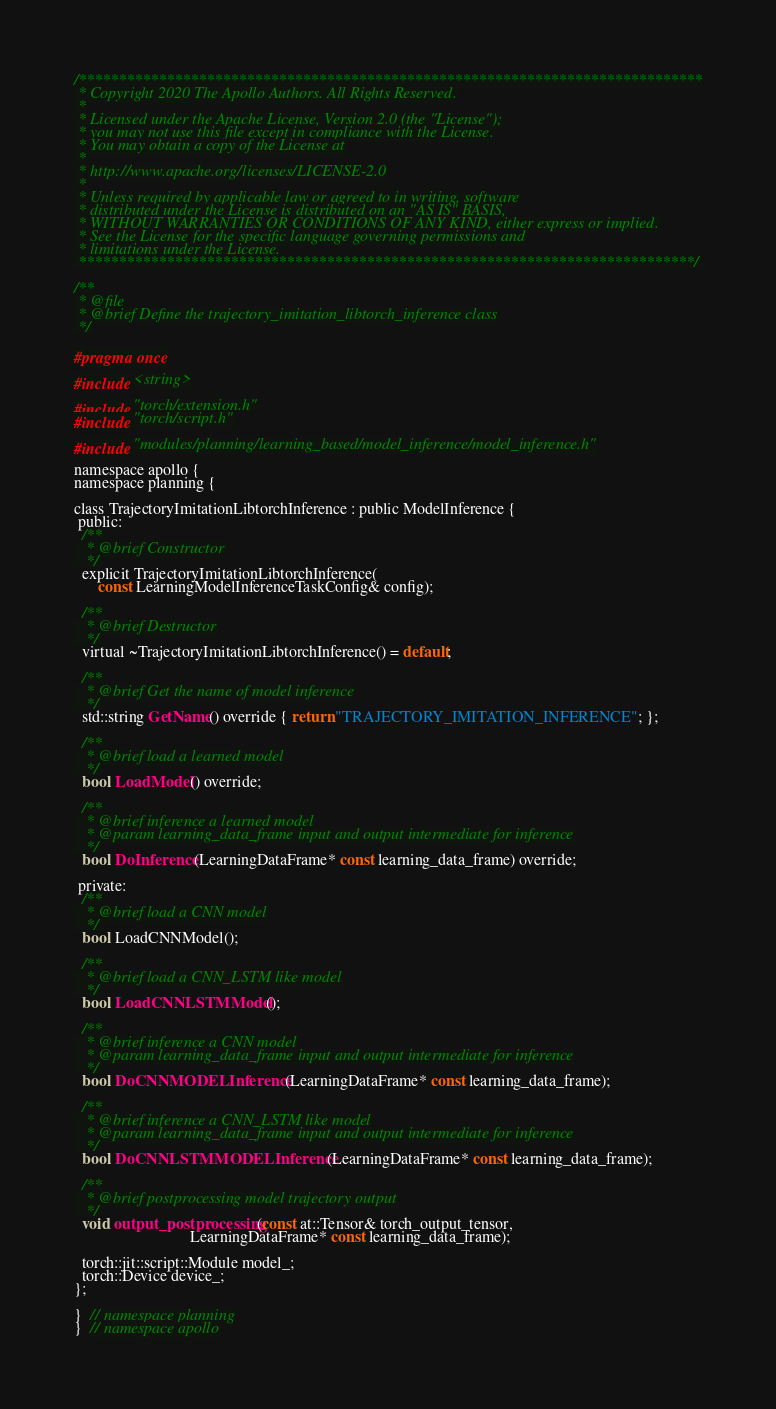Convert code to text. <code><loc_0><loc_0><loc_500><loc_500><_C_>/******************************************************************************
 * Copyright 2020 The Apollo Authors. All Rights Reserved.
 *
 * Licensed under the Apache License, Version 2.0 (the "License");
 * you may not use this file except in compliance with the License.
 * You may obtain a copy of the License at
 *
 * http://www.apache.org/licenses/LICENSE-2.0
 *
 * Unless required by applicable law or agreed to in writing, software
 * distributed under the License is distributed on an "AS IS" BASIS,
 * WITHOUT WARRANTIES OR CONDITIONS OF ANY KIND, either express or implied.
 * See the License for the specific language governing permissions and
 * limitations under the License.
 *****************************************************************************/

/**
 * @file
 * @brief Define the trajectory_imitation_libtorch_inference class
 */

#pragma once

#include <string>

#include "torch/extension.h"
#include "torch/script.h"

#include "modules/planning/learning_based/model_inference/model_inference.h"

namespace apollo {
namespace planning {

class TrajectoryImitationLibtorchInference : public ModelInference {
 public:
  /**
   * @brief Constructor
   */
  explicit TrajectoryImitationLibtorchInference(
      const LearningModelInferenceTaskConfig& config);

  /**
   * @brief Destructor
   */
  virtual ~TrajectoryImitationLibtorchInference() = default;

  /**
   * @brief Get the name of model inference
   */
  std::string GetName() override { return "TRAJECTORY_IMITATION_INFERENCE"; };

  /**
   * @brief load a learned model
   */
  bool LoadModel() override;

  /**
   * @brief inference a learned model
   * @param learning_data_frame input and output intermediate for inference
   */
  bool DoInference(LearningDataFrame* const learning_data_frame) override;

 private:
  /**
   * @brief load a CNN model
   */
  bool LoadCNNModel();

  /**
   * @brief load a CNN_LSTM like model
   */
  bool LoadCNNLSTMModel();

  /**
   * @brief inference a CNN model
   * @param learning_data_frame input and output intermediate for inference
   */
  bool DoCNNMODELInference(LearningDataFrame* const learning_data_frame);

  /**
   * @brief inference a CNN_LSTM like model
   * @param learning_data_frame input and output intermediate for inference
   */
  bool DoCNNLSTMMODELInference(LearningDataFrame* const learning_data_frame);

  /**
   * @brief postprocessing model trajectory output
   */
  void output_postprocessing(const at::Tensor& torch_output_tensor,
                             LearningDataFrame* const learning_data_frame);

  torch::jit::script::Module model_;
  torch::Device device_;
};

}  // namespace planning
}  // namespace apollo
</code> 